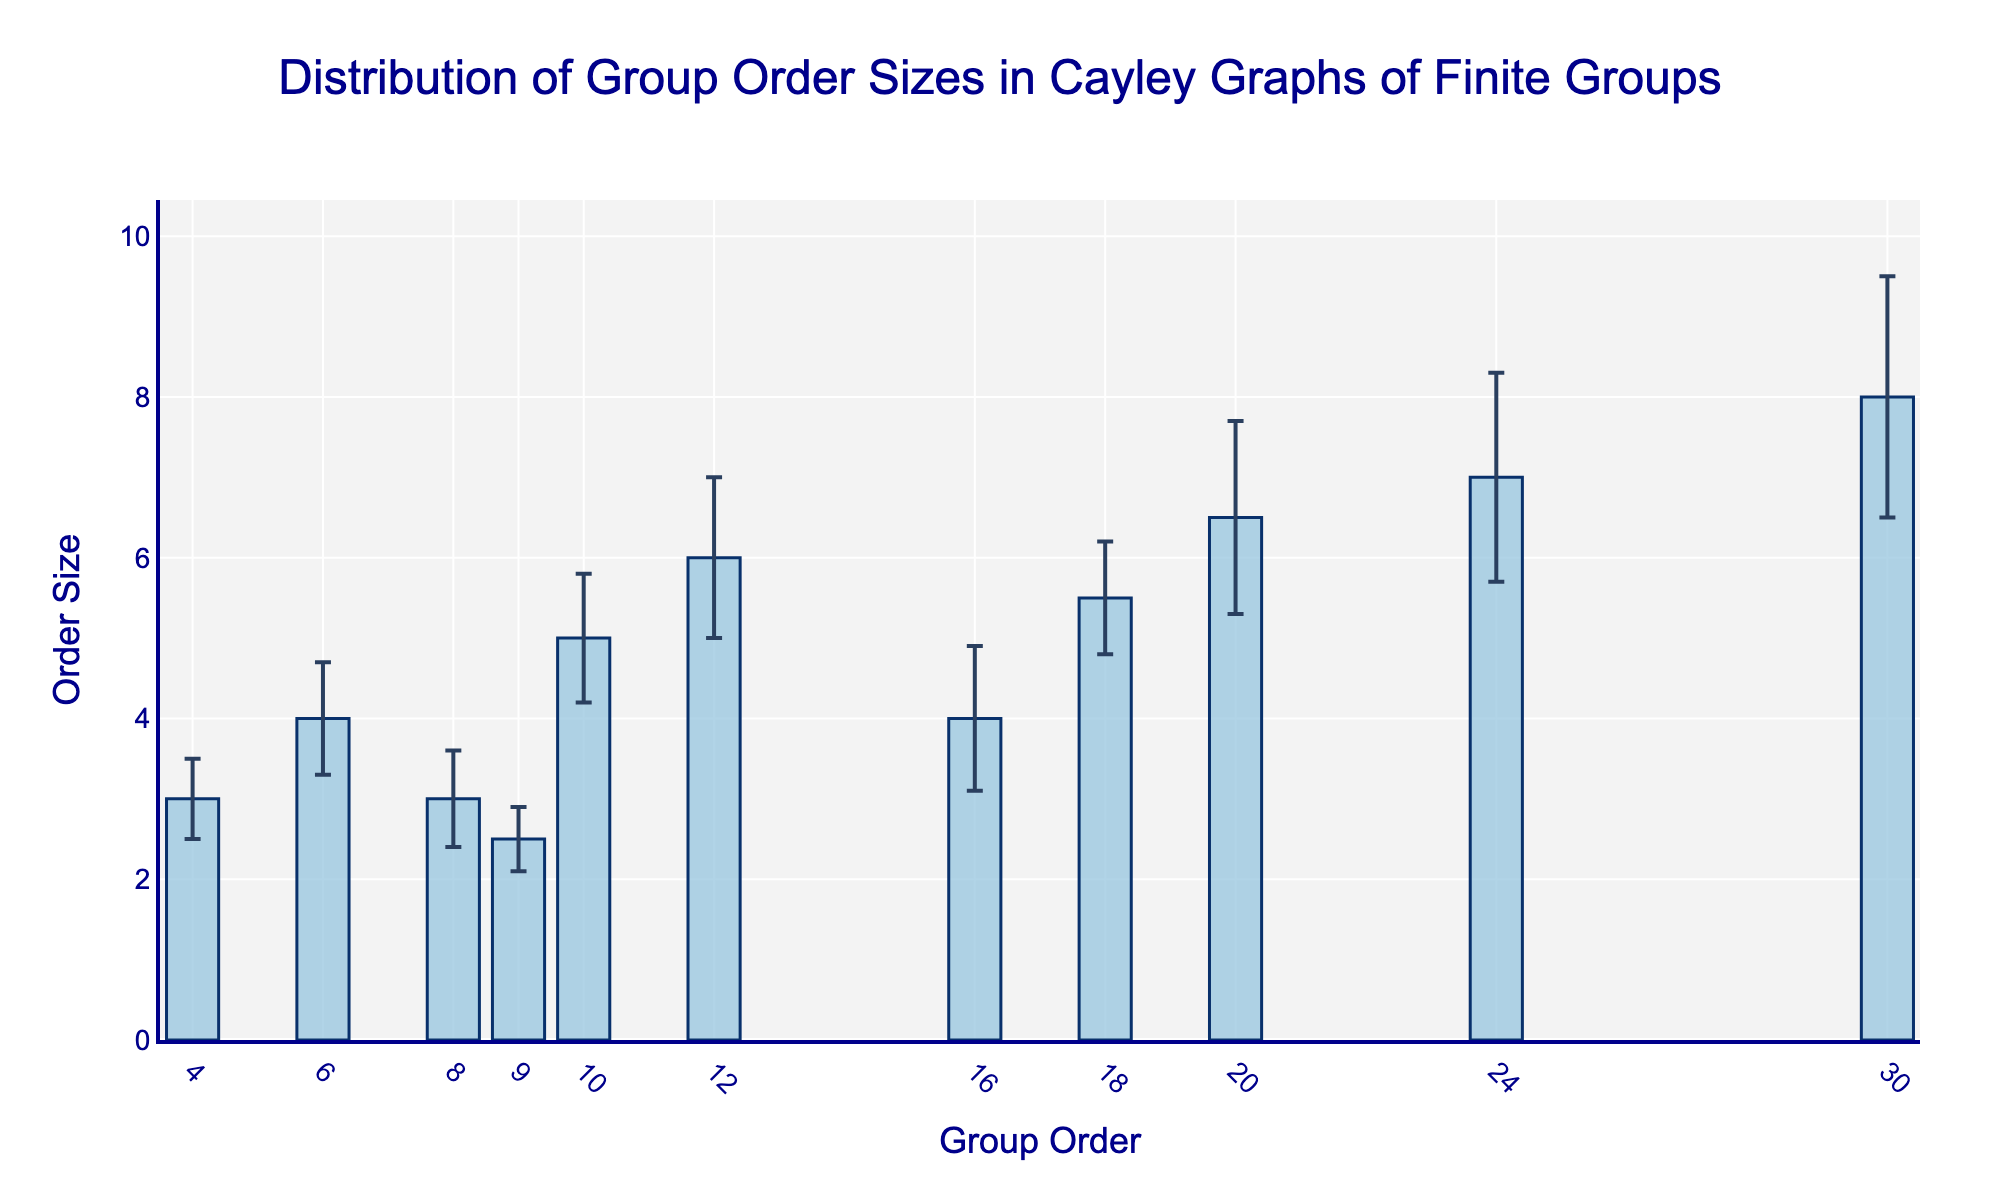What's the title of the figure? Look at the top of the figure where the title is usually placed.
Answer: Distribution of Group Order Sizes in Cayley Graphs of Finite Groups What is the order size of the group with order 24? Find the bar that corresponds to the group order of 24 on the x-axis and identify its height on the y-axis.
Answer: 7 Which group has the smallest standard deviation and what is its value? Find the smallest error bar by visual inspection and check the corresponding group order on the x-axis.
Answer: Cyclic Group C9, 0.4 What's the average order size of the groups with order sizes less than 4? Identify the bars with order sizes less than 4, sum their order sizes, and then calculate the average.
Answer: (3 + 3 + 2.5) / 3 = 2.83 For which group order is the error bar the largest? Compare the lengths of all the error bars to find the largest one.
Answer: Group order 30 What's the difference between the order sizes of the Cyclic Group C18 and the Dihedral Group D6? Identify the order sizes of both groups and subtract the smaller one from the larger one.
Answer: 5.5 - 6 = -0.5 How many groups have an order size greater than or equal to 5? Count the number of bars whose heights are 5 or more.
Answer: 5 Which group has the lowest order size value and what is it? Find the shortest bar and identify its height on the y-axis and corresponding group on the x-axis.
Answer: Cyclic Group C9, 2.5 What is the combined order size of groups with group orders 6 and 20? Add the order sizes of the groups with group orders 6 and 20.
Answer: 4 + 6.5 = 10.5 Which group has an order size closest to the mean of all recorded order sizes? Calculate the mean of all order sizes and find the group whose order size is closest to this value. The total sum of order sizes is 54 (3 + 4 + 3 + 2.5 + 5 + 6 + 4 + 5.5 + 6.5 + 7 + 8). Average = 54 / 11 ≈ 4.91.
Answer: Cyclic Group C18, 5.5 